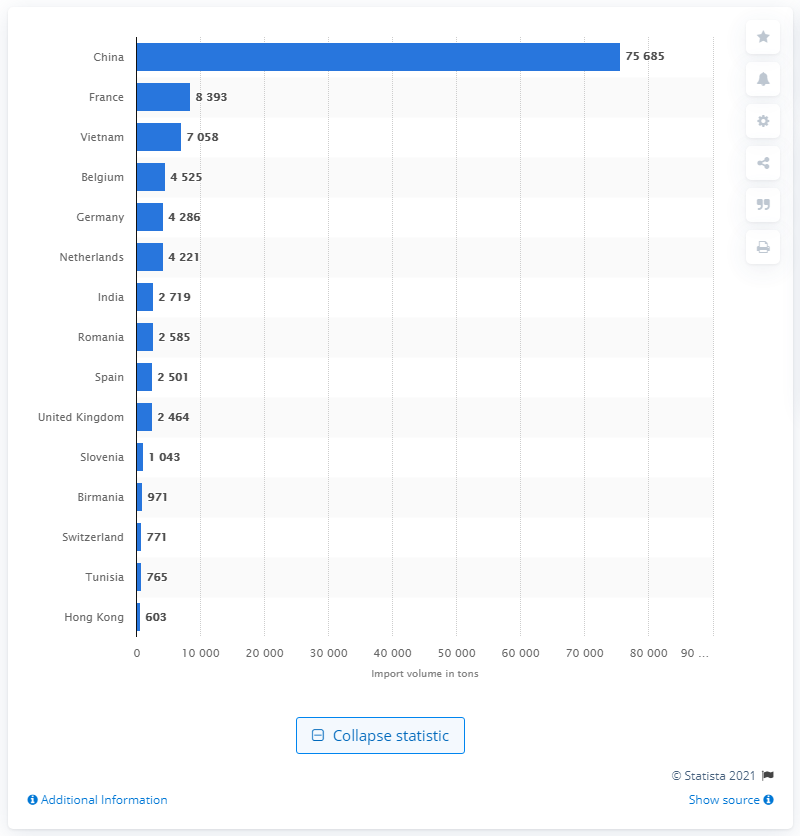Draw attention to some important aspects in this diagram. In 2019, France was the second largest supplier of leather products to Italy. In 2019, Italy imported leather products and substitutes primarily from China. 